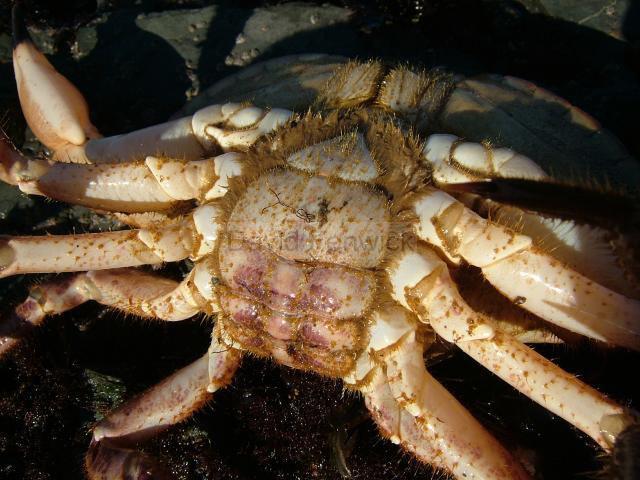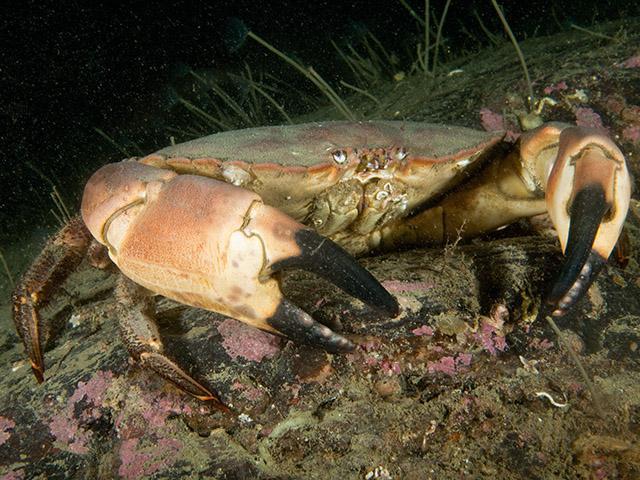The first image is the image on the left, the second image is the image on the right. For the images displayed, is the sentence "The crabs have the same orientation." factually correct? Answer yes or no. No. The first image is the image on the left, the second image is the image on the right. For the images shown, is this caption "Each image shows a top-view of a crab with its face and its larger front claws at the top, and its shell facing forward." true? Answer yes or no. No. 